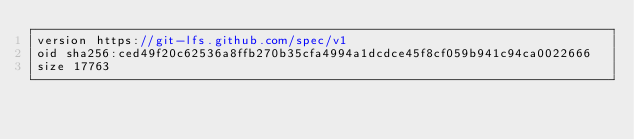Convert code to text. <code><loc_0><loc_0><loc_500><loc_500><_C_>version https://git-lfs.github.com/spec/v1
oid sha256:ced49f20c62536a8ffb270b35cfa4994a1dcdce45f8cf059b941c94ca0022666
size 17763
</code> 